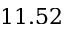<formula> <loc_0><loc_0><loc_500><loc_500>1 1 . 5 2</formula> 